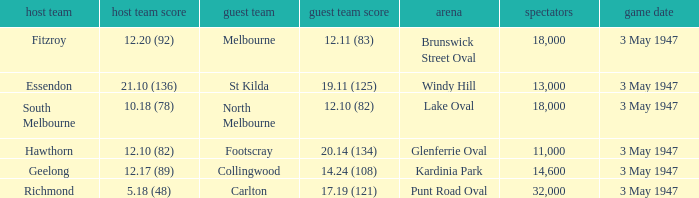In the game where the home team scored 12.17 (89), who was the home team? Geelong. 